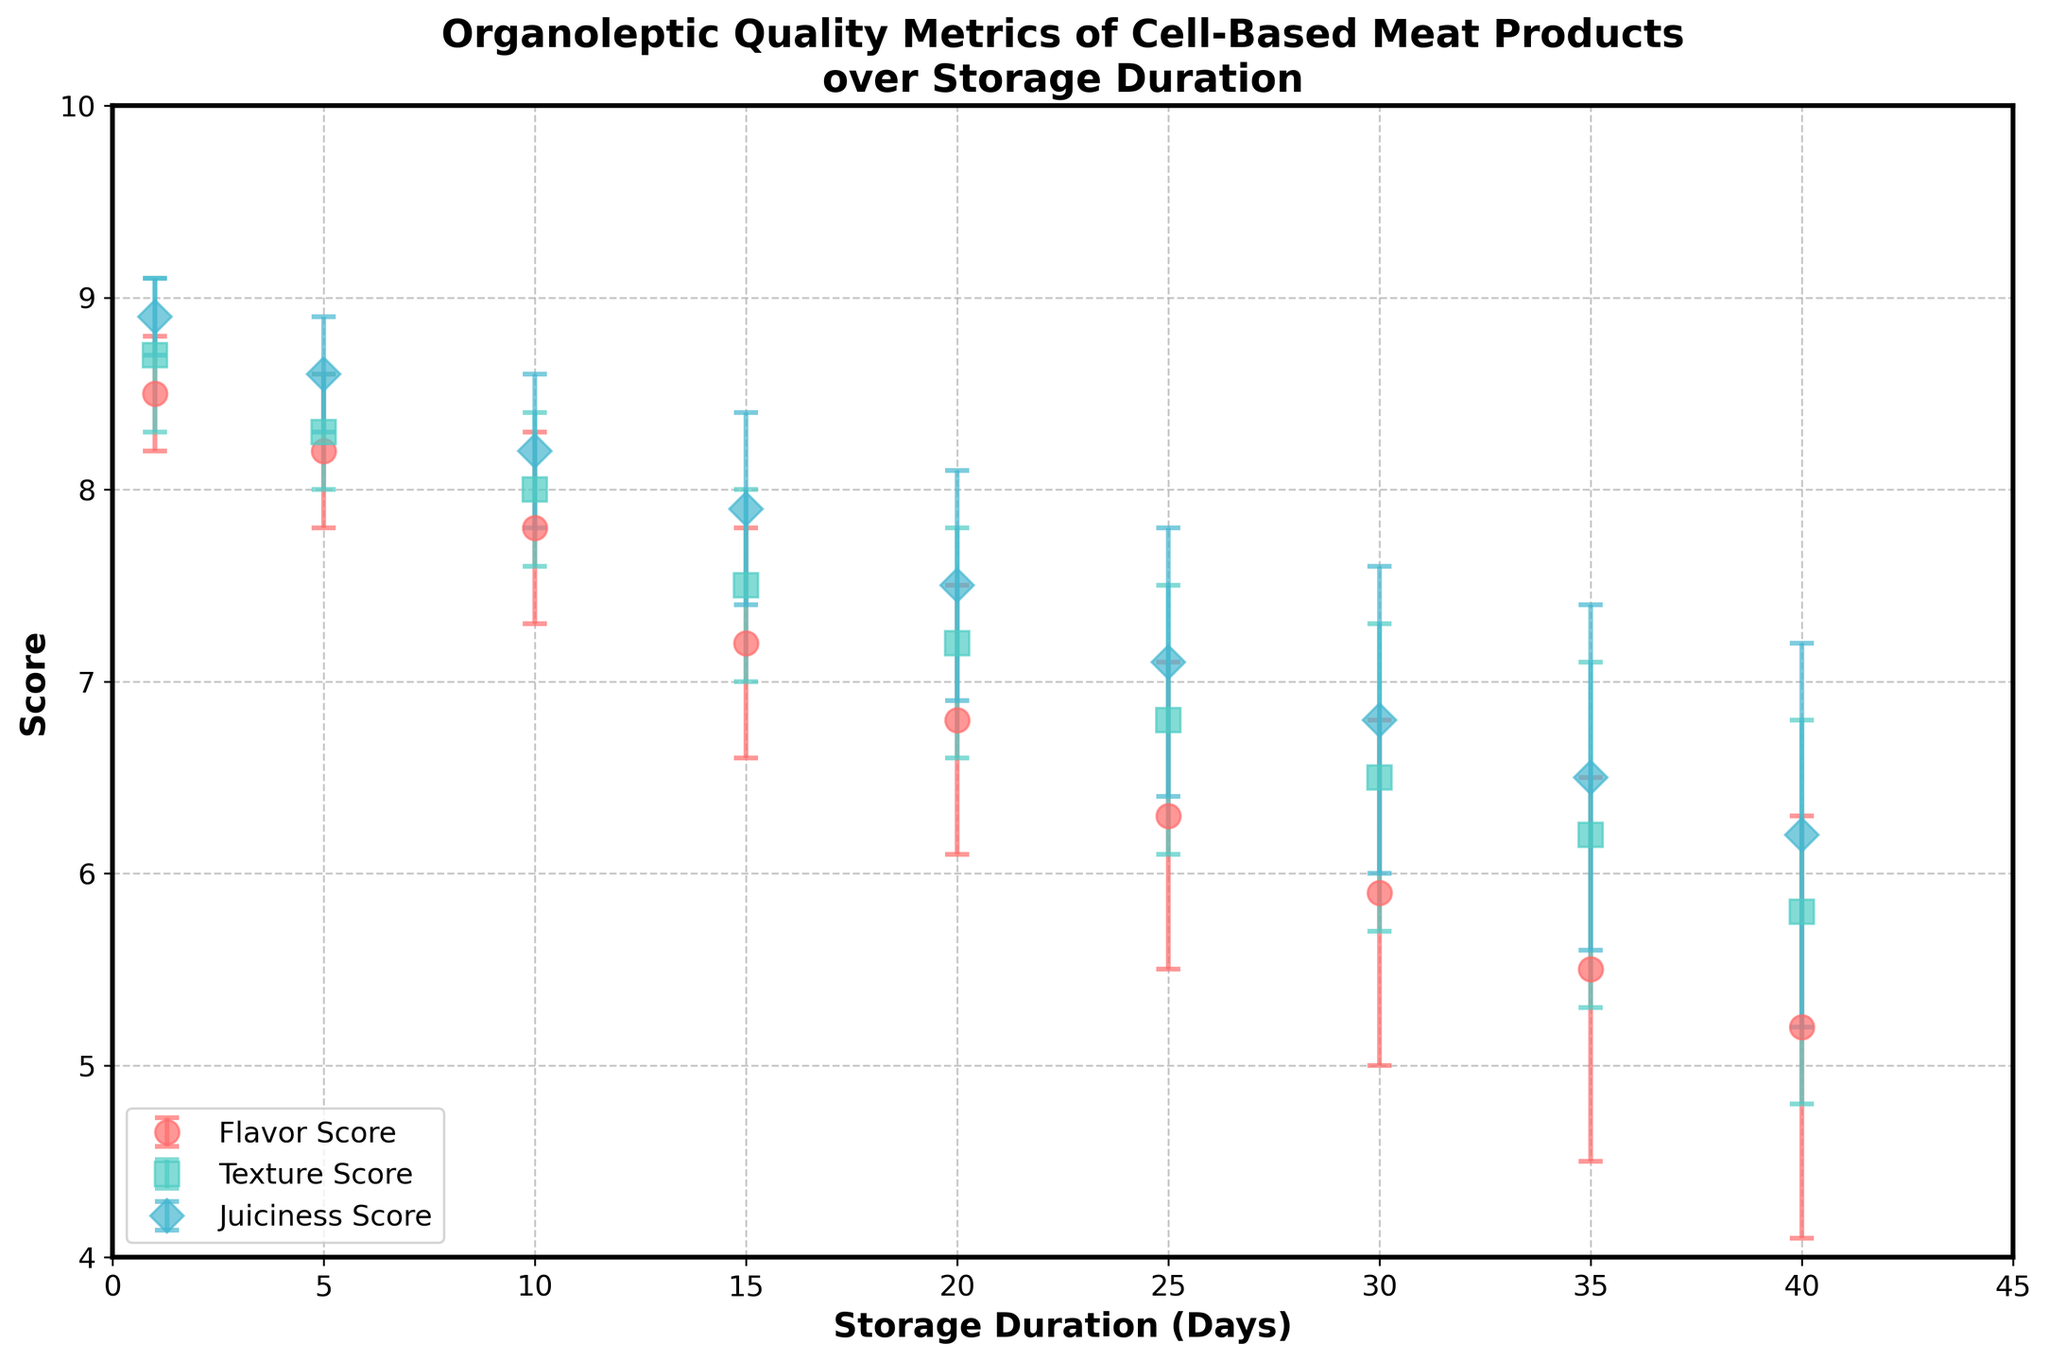What's the title of the graph? The title is prominently displayed at the top of the graph. It appears in a larger and bold font compared to other text elements.
Answer: Organoleptic Quality Metrics of Cell-Based Meat Products over Storage Duration How many different organoleptic quality metrics are displayed in the scatter plot? The legend in the lower-left corner of the plot shows three different colored labels, each representing a unique organoleptic quality metric.
Answer: Three What are the colors representing Flavor Score, Texture Score, and Juiciness Score, respectively? The legend shows that Flavor Score is represented in red, Texture Score in teal, and Juiciness Score in light blue.
Answer: Red, Teal, Light Blue What is the average Flavor Score over the entire storage duration period? Sum the Flavor Scores (8.5 + 8.2 + 7.8 + 7.2 + 6.8 + 6.3 + 5.9 + 5.5 + 5.2) and then divide by the number of points (9): (8.5 + 8.2 + 7.8 + 7.2 + 6.8 + 6.3 + 5.9 + 5.5 + 5.2) / 9 = 61.4 / 9.
Answer: 6.82 At which storage duration do the Flavor Scores fall below 7? Examine the x-axis values for Flavor Scores below 7. The scores fall below 7 starting from 15 days of storage onward.
Answer: 15 days Which organoleptic metric shows the steepest decline as storage duration increases? By visually inspecting the slopes of the error lines and points across storage durations in the graph, the Flavor Score shows the steepest decline in comparison to Texture and Juiciness Scores.
Answer: Flavor Score Do any of the quality metrics increase as storage duration increases? All the plotted lines for Flavor Score, Texture Score, and Juiciness Score demonstrate a downward trend as storage duration increases.
Answer: No What is the largest error bar observed, and for which metric and storage duration does it occur? The largest error bar has a length of 1.1, observed for Flavor Score and at 40 days storage duration.
Answer: Flavor Score, 40 days Between Texture Score and Juiciness Score, which metric shows less variation in its error bars? By visually comparing the lengths of the error bars, Texture Score error bars are shorter and more consistent, indicating less variation compared to Juiciness Score.
Answer: Texture Score 